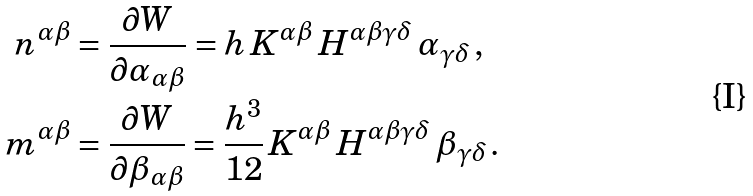Convert formula to latex. <formula><loc_0><loc_0><loc_500><loc_500>n ^ { \alpha \beta } & = \frac { \partial W } { \partial \alpha _ { \alpha \beta } } = h \, K ^ { \alpha \beta } \, H ^ { \alpha \beta \gamma \delta } \, \alpha _ { \gamma \delta } \, , \\ m ^ { \alpha \beta } & = \frac { \partial W } { \partial \beta _ { \alpha \beta } } = \frac { h ^ { 3 } } { 1 2 } \, K ^ { \alpha \beta } \, H ^ { \alpha \beta \gamma \delta } \, \beta _ { \gamma \delta } \, . \\</formula> 